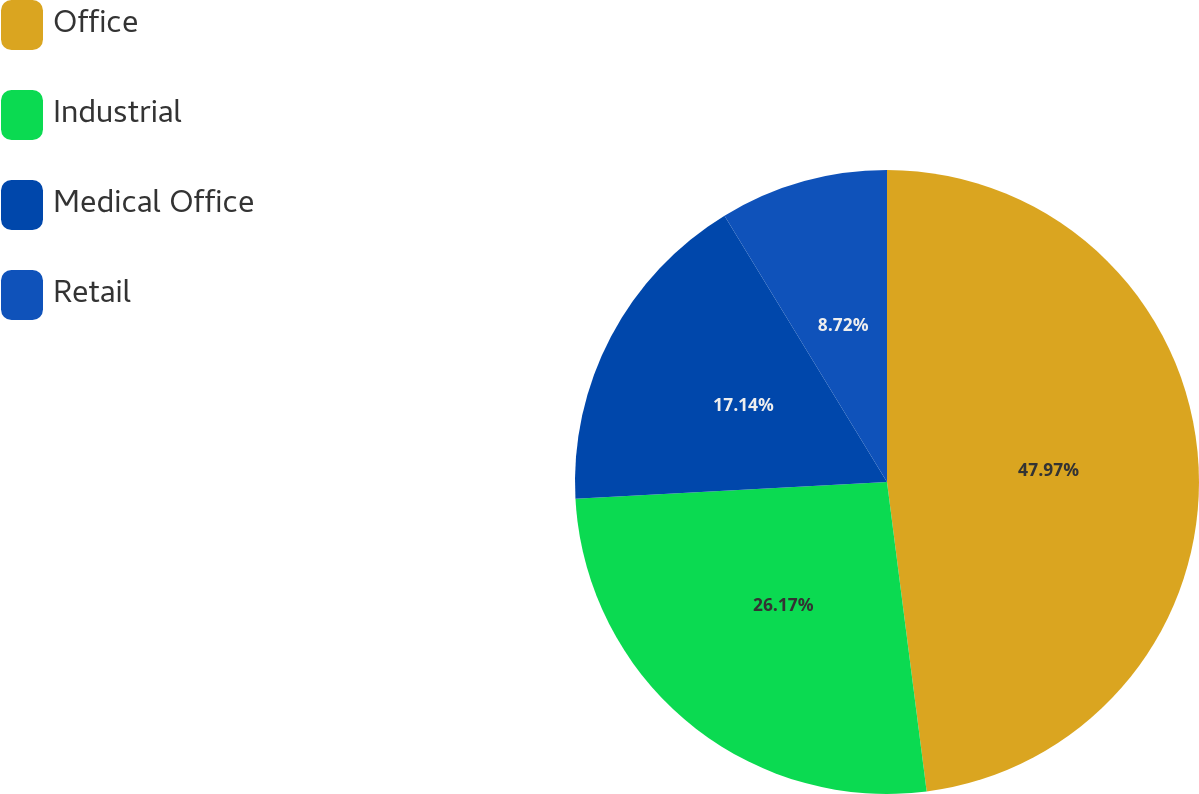Convert chart. <chart><loc_0><loc_0><loc_500><loc_500><pie_chart><fcel>Office<fcel>Industrial<fcel>Medical Office<fcel>Retail<nl><fcel>47.97%<fcel>26.17%<fcel>17.14%<fcel>8.72%<nl></chart> 